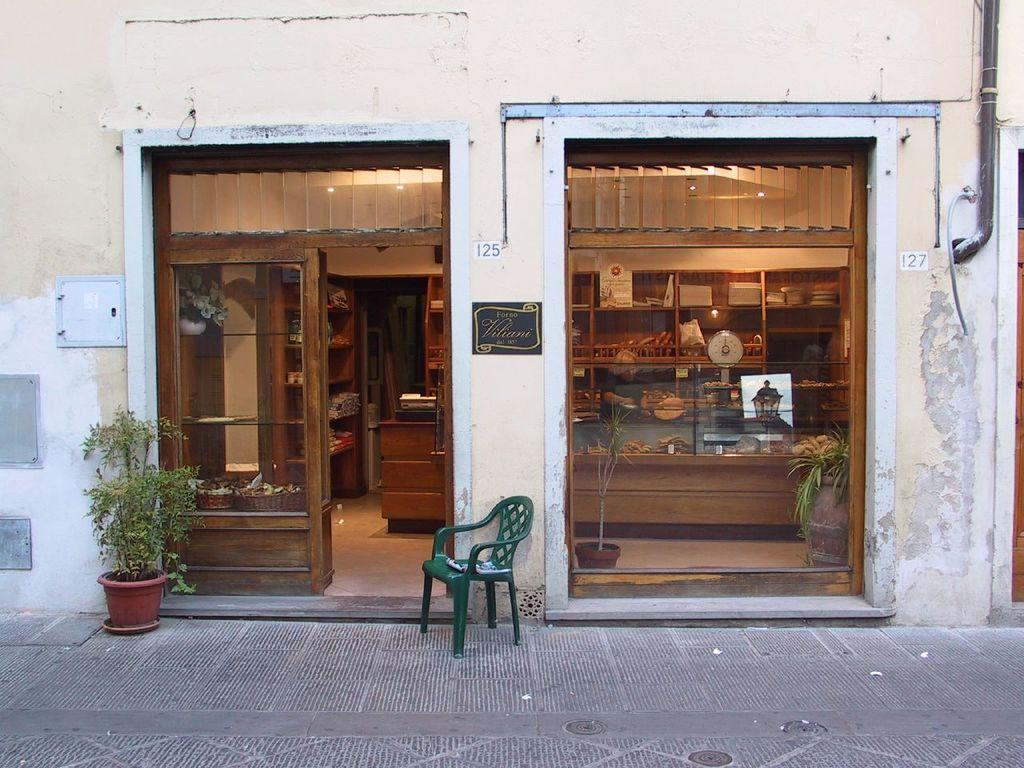What type of container is visible in the image? There is a glass in the image. What type of furniture is present in the image? There is a chair in the image. What type of storage is available in the image? There are cupboards in the image. What type of decorative item is present in the image? There is a flower pot with a plant in the image. What type of accessory is present in the image? There is a basket in the image. What type of architectural feature is present in the image? There is a wall in the image. What type of surface is present in the image? There is a floor in the image. What type of plumbing feature is present in the image? There is a pipe in the image. How many flowers are growing in the cap in the image? There is no cap or flowers present in the image. What type of credit card is visible in the image? There is no credit card present in the image. 